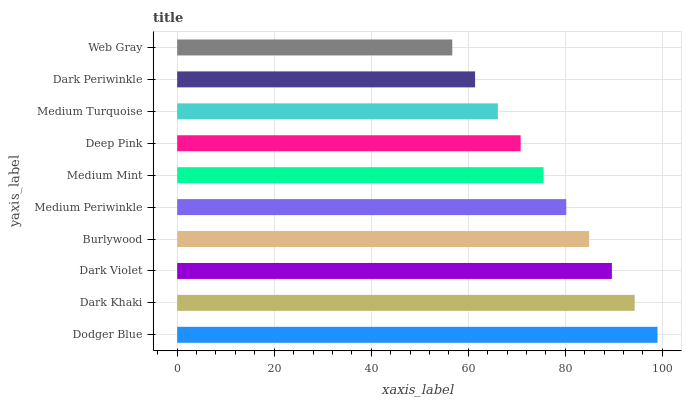Is Web Gray the minimum?
Answer yes or no. Yes. Is Dodger Blue the maximum?
Answer yes or no. Yes. Is Dark Khaki the minimum?
Answer yes or no. No. Is Dark Khaki the maximum?
Answer yes or no. No. Is Dodger Blue greater than Dark Khaki?
Answer yes or no. Yes. Is Dark Khaki less than Dodger Blue?
Answer yes or no. Yes. Is Dark Khaki greater than Dodger Blue?
Answer yes or no. No. Is Dodger Blue less than Dark Khaki?
Answer yes or no. No. Is Medium Periwinkle the high median?
Answer yes or no. Yes. Is Medium Mint the low median?
Answer yes or no. Yes. Is Medium Turquoise the high median?
Answer yes or no. No. Is Dark Khaki the low median?
Answer yes or no. No. 